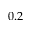<formula> <loc_0><loc_0><loc_500><loc_500>0 . 2</formula> 